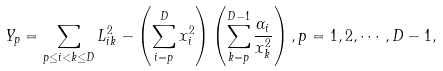<formula> <loc_0><loc_0><loc_500><loc_500>Y _ { p } = \sum _ { p \leq i < k \leq D } L ^ { 2 } _ { i k } - \left ( \sum _ { i = p } ^ { D } x _ { i } ^ { 2 } \right ) \left ( \sum _ { k = p } ^ { D - 1 } \frac { \alpha _ { i } } { x _ { k } ^ { 2 } } \right ) , p = 1 , 2 , \cdots , D - 1 ,</formula> 